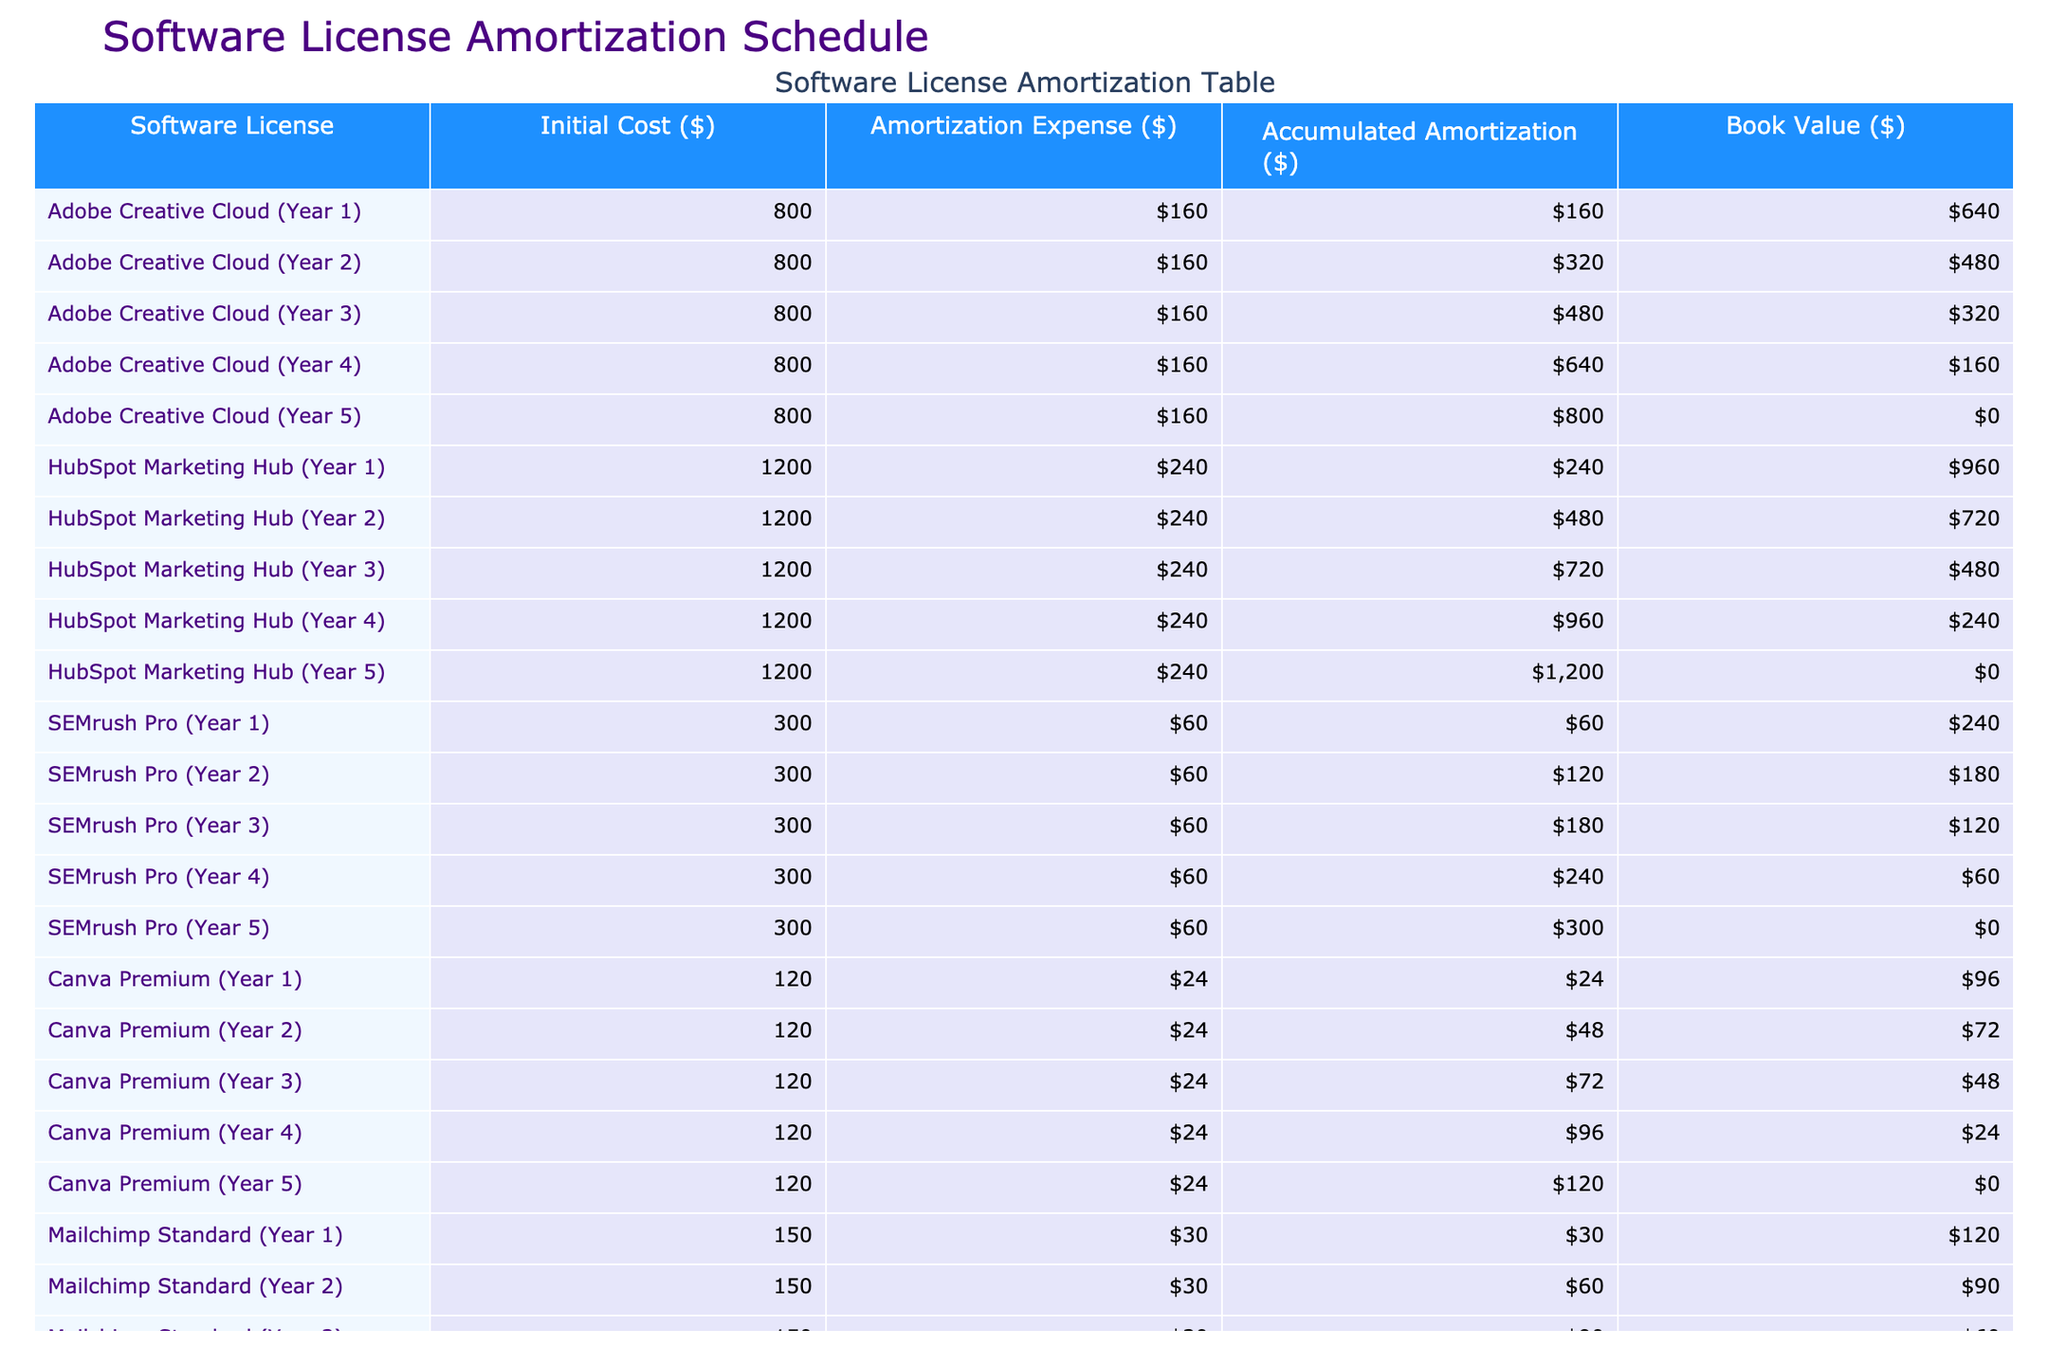What is the amortization expense for Adobe Creative Cloud in Year 3? The amortization expense for Adobe Creative Cloud in Year 3 is listed directly in the table under the corresponding year, which shows it to be 160 dollars.
Answer: 160 What is the accumulated amortization for HubSpot Marketing Hub by Year 4? To find the accumulated amortization, look at the HubSpot Marketing Hub row for Year 4, which shows the accumulated amount as 960 dollars.
Answer: 960 Is the book value of SEMrush Pro zero in the final year? The final year for SEMrush Pro is Year 5, and looking at the table, the book value listed for that year is indeed zero, confirming the statement is true.
Answer: Yes Which software license has the highest amortization expense in any given year? By reviewing the amortization expenses for all software in each year, the maximum listed expense occurs with HubSpot Marketing Hub, with an expense of 240 dollars in Year 1.
Answer: HubSpot Marketing Hub What is the total accumulated amortization for Canva Premium after all five years? The total accumulated amortization for Canva Premium is found in Year 5 from the table, showing 120 dollars accumulated over the five years.
Answer: 120 If we want to compare the total initial costs of all software licenses, what would that total be? Summing all the initial costs from the table: 800 (Adobe) + 1200 (HubSpot) + 300 (SEMrush) + 120 (Canva) + 150 (Mailchimp) gives a total of 2670 dollars.
Answer: 2670 What is the average book value of all software licenses after their complete amortization? After all software licenses are fully amortized (represented by Year 5), the book values are: 0, 0, 0, 0, 0 for each license. The total is 0, and the average of these five values is also zero.
Answer: 0 Was the amortization expense for Mailchimp Standard indicative of a similar pattern compared to Adobe Creative Cloud? Analyzing the amortization expenses for both licenses shows that both have a consistent amortization expense of 30 dollars for Mailchimp and 160 dollars for Adobe Creative Cloud, indicating a distinct expense pattern, as Mailchimp's expense is lower.
Answer: No What is the accumulated amortization for SEMrush Pro in Year 2? By directly checking the table, the accumulated amortization for SEMrush Pro in Year 2 is shown to be 120 dollars.
Answer: 120 